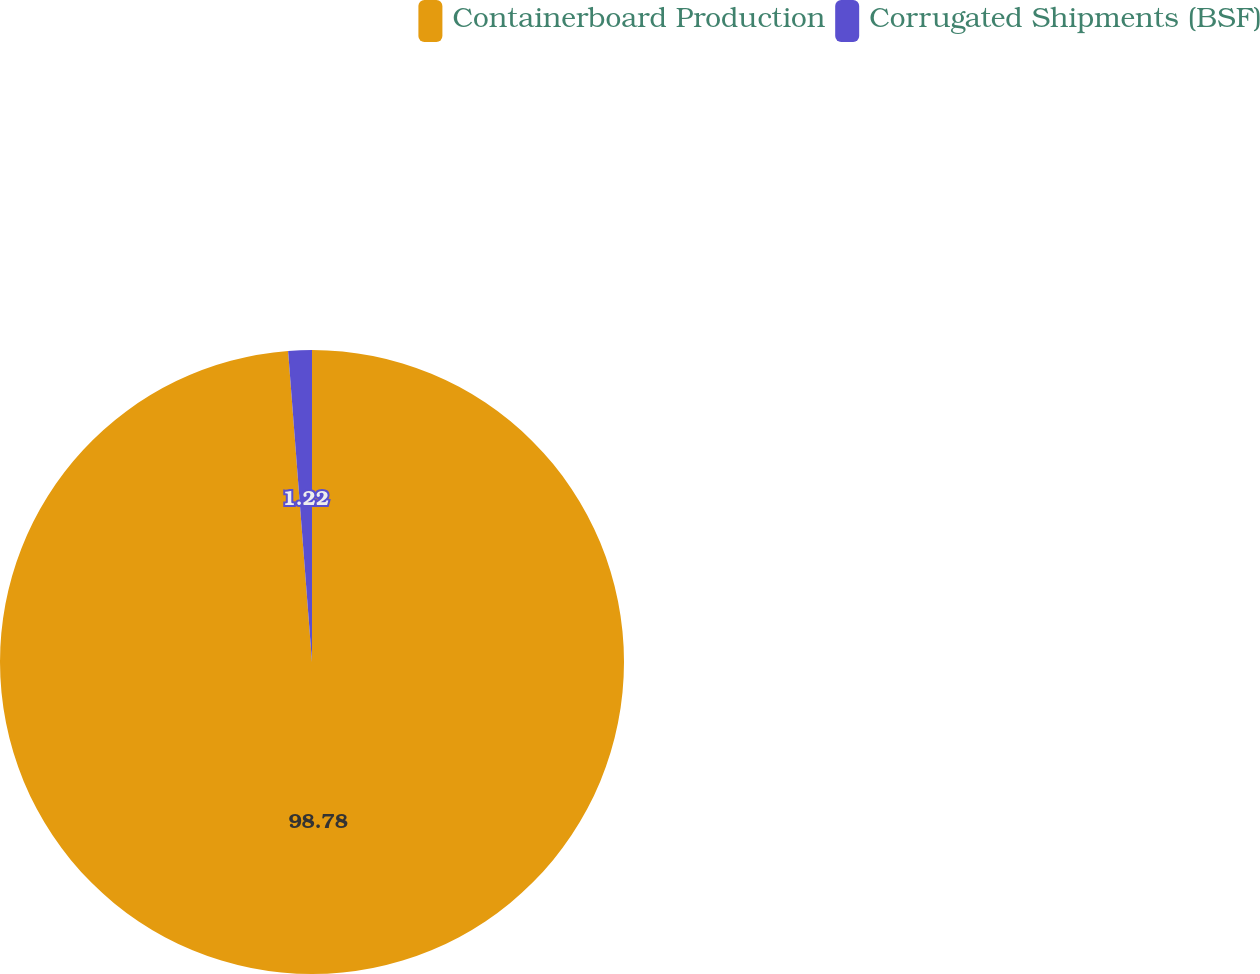Convert chart. <chart><loc_0><loc_0><loc_500><loc_500><pie_chart><fcel>Containerboard Production<fcel>Corrugated Shipments (BSF)<nl><fcel>98.78%<fcel>1.22%<nl></chart> 